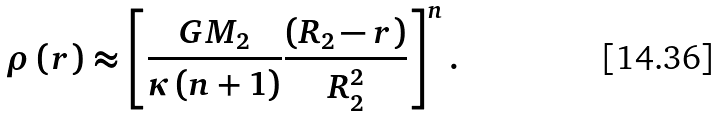Convert formula to latex. <formula><loc_0><loc_0><loc_500><loc_500>\rho \left ( r \right ) \approx \left [ \frac { G M _ { 2 } } { \kappa \left ( n + 1 \right ) } \frac { \left ( R _ { 2 } - r \right ) } { R ^ { 2 } _ { 2 } } \right ] ^ { n } .</formula> 